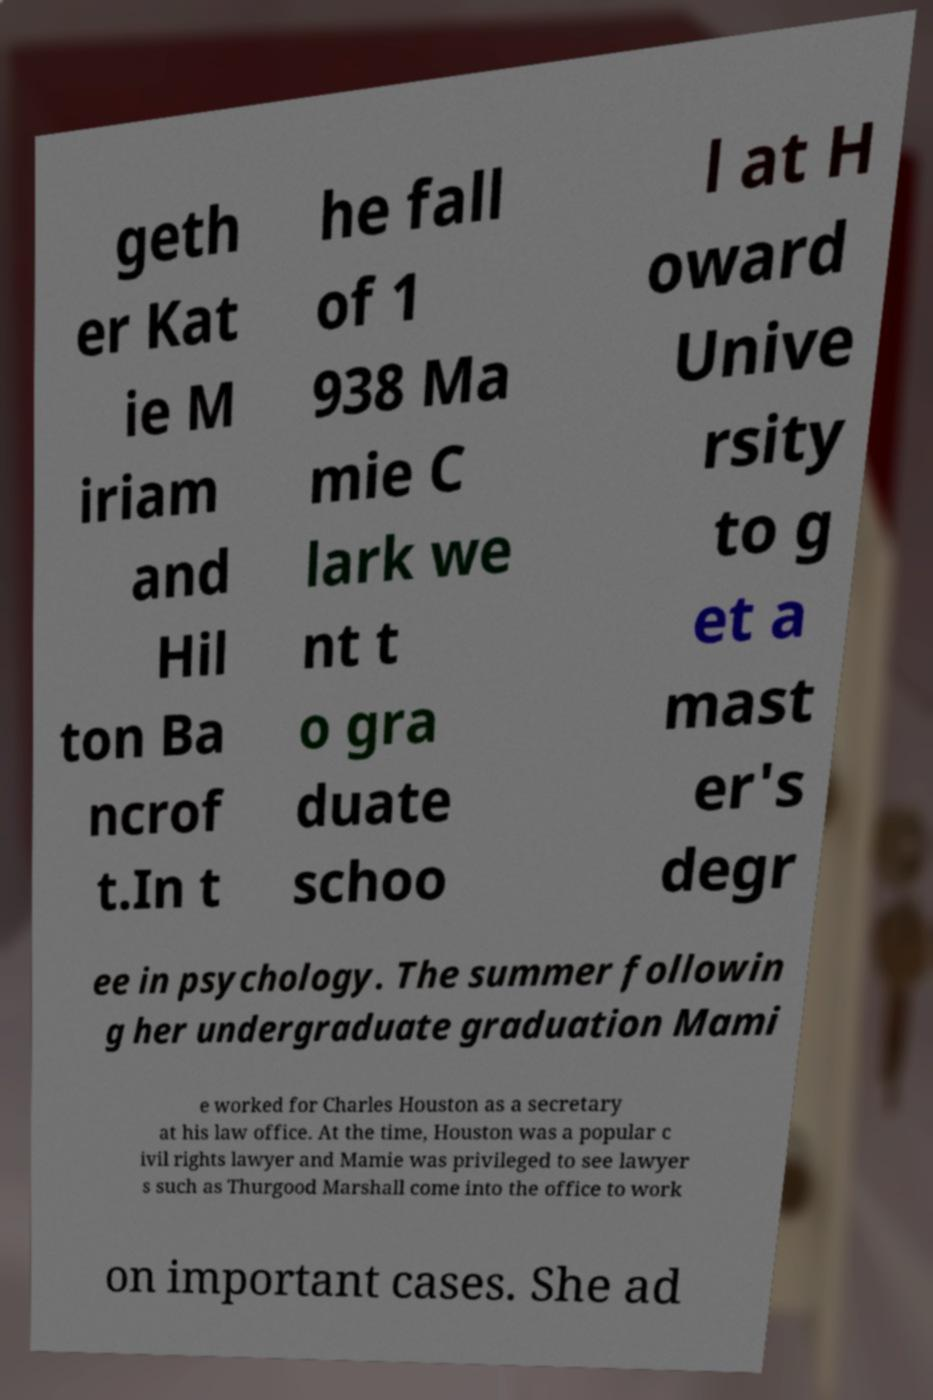Please read and relay the text visible in this image. What does it say? geth er Kat ie M iriam and Hil ton Ba ncrof t.In t he fall of 1 938 Ma mie C lark we nt t o gra duate schoo l at H oward Unive rsity to g et a mast er's degr ee in psychology. The summer followin g her undergraduate graduation Mami e worked for Charles Houston as a secretary at his law office. At the time, Houston was a popular c ivil rights lawyer and Mamie was privileged to see lawyer s such as Thurgood Marshall come into the office to work on important cases. She ad 